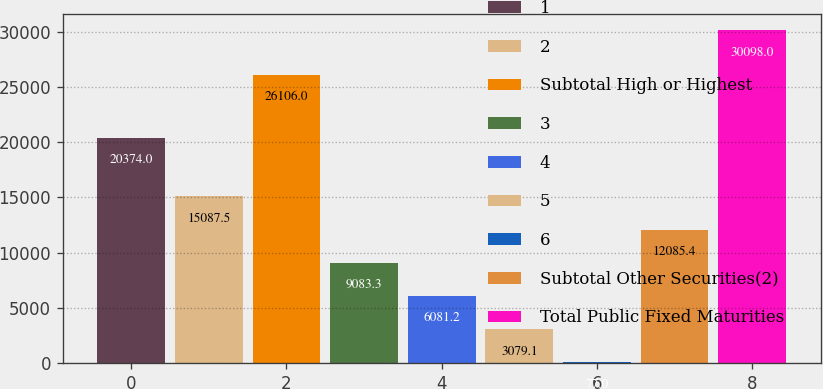Convert chart to OTSL. <chart><loc_0><loc_0><loc_500><loc_500><bar_chart><fcel>1<fcel>2<fcel>Subtotal High or Highest<fcel>3<fcel>4<fcel>5<fcel>6<fcel>Subtotal Other Securities(2)<fcel>Total Public Fixed Maturities<nl><fcel>20374<fcel>15087.5<fcel>26106<fcel>9083.3<fcel>6081.2<fcel>3079.1<fcel>77<fcel>12085.4<fcel>30098<nl></chart> 